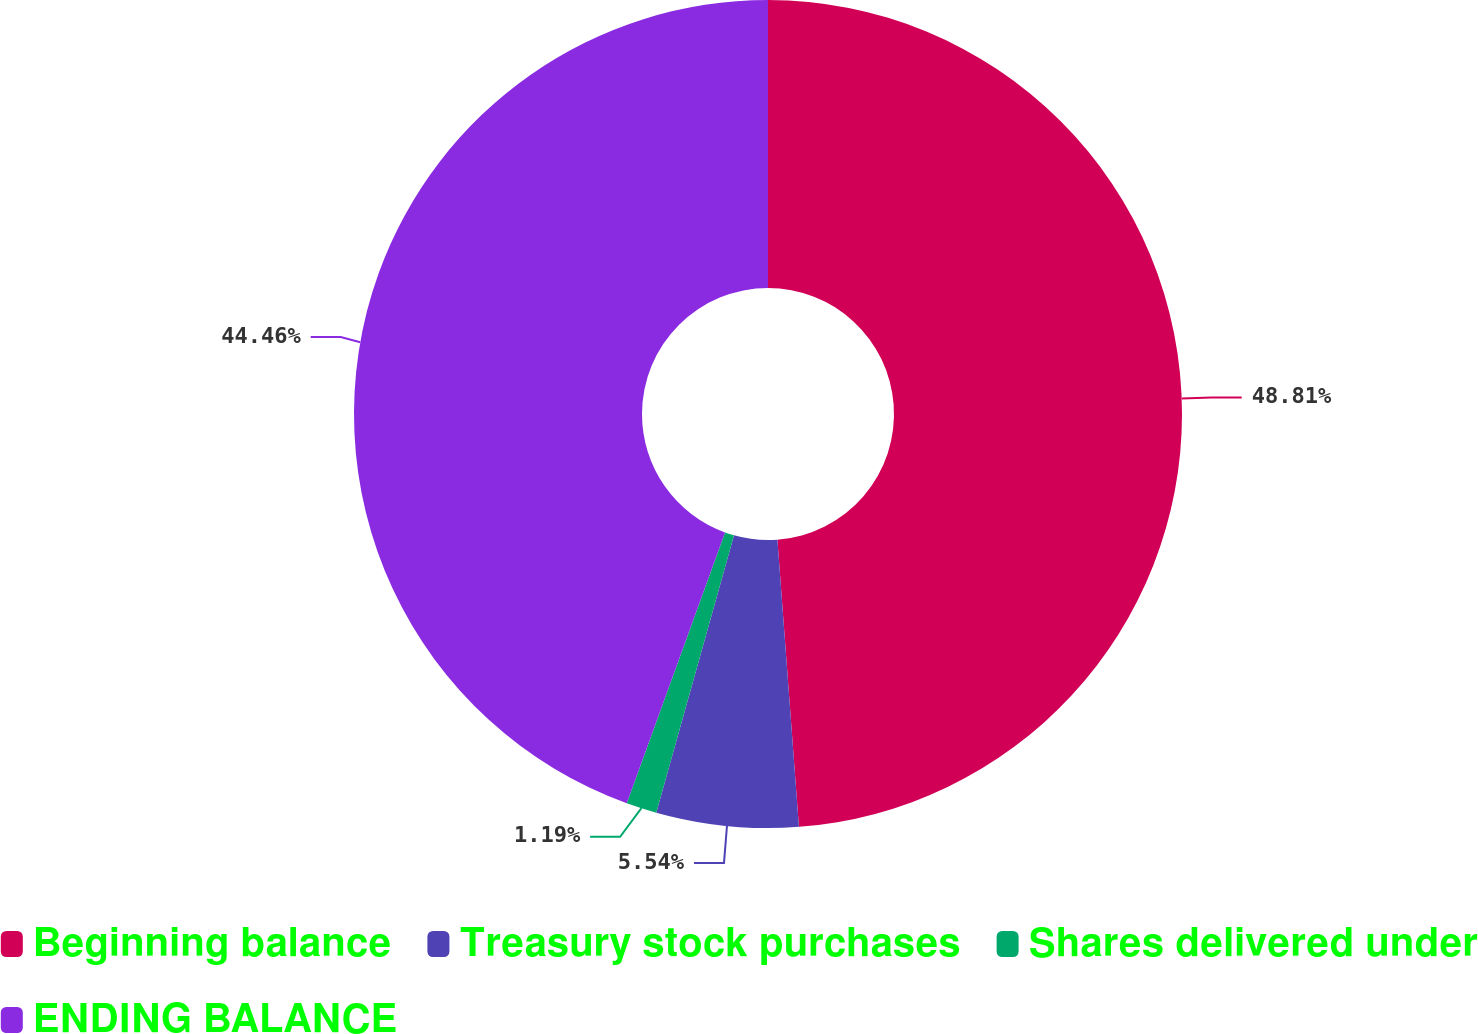Convert chart. <chart><loc_0><loc_0><loc_500><loc_500><pie_chart><fcel>Beginning balance<fcel>Treasury stock purchases<fcel>Shares delivered under<fcel>ENDING BALANCE<nl><fcel>48.81%<fcel>5.54%<fcel>1.19%<fcel>44.46%<nl></chart> 